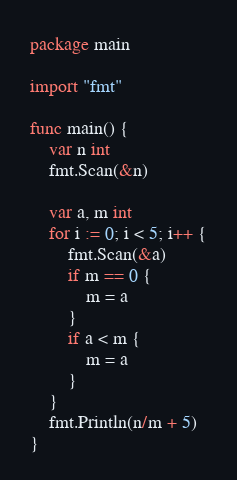Convert code to text. <code><loc_0><loc_0><loc_500><loc_500><_Go_>package main

import "fmt"

func main() {
	var n int
	fmt.Scan(&n)

	var a, m int
	for i := 0; i < 5; i++ {
		fmt.Scan(&a)
		if m == 0 {
			m = a
		}
		if a < m {
			m = a
		}
	}
	fmt.Println(n/m + 5)
}
</code> 